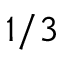<formula> <loc_0><loc_0><loc_500><loc_500>1 / 3</formula> 